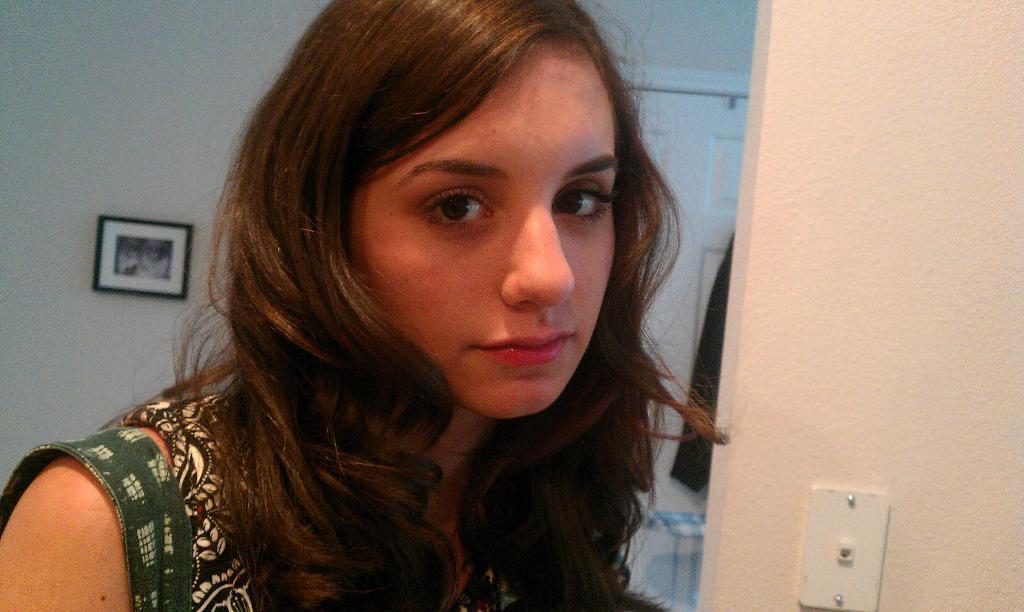Who is present in the image? There is a woman in the image. What can be seen in the background of the image? There is a wall in the background of the image. What is on the wall in the image? There is a photo frame on the wall. Can you see a tiger swimming in the image? No, there is no tiger or swimming activity present in the image. 